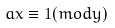<formula> <loc_0><loc_0><loc_500><loc_500>a x \equiv 1 ( m o d y )</formula> 